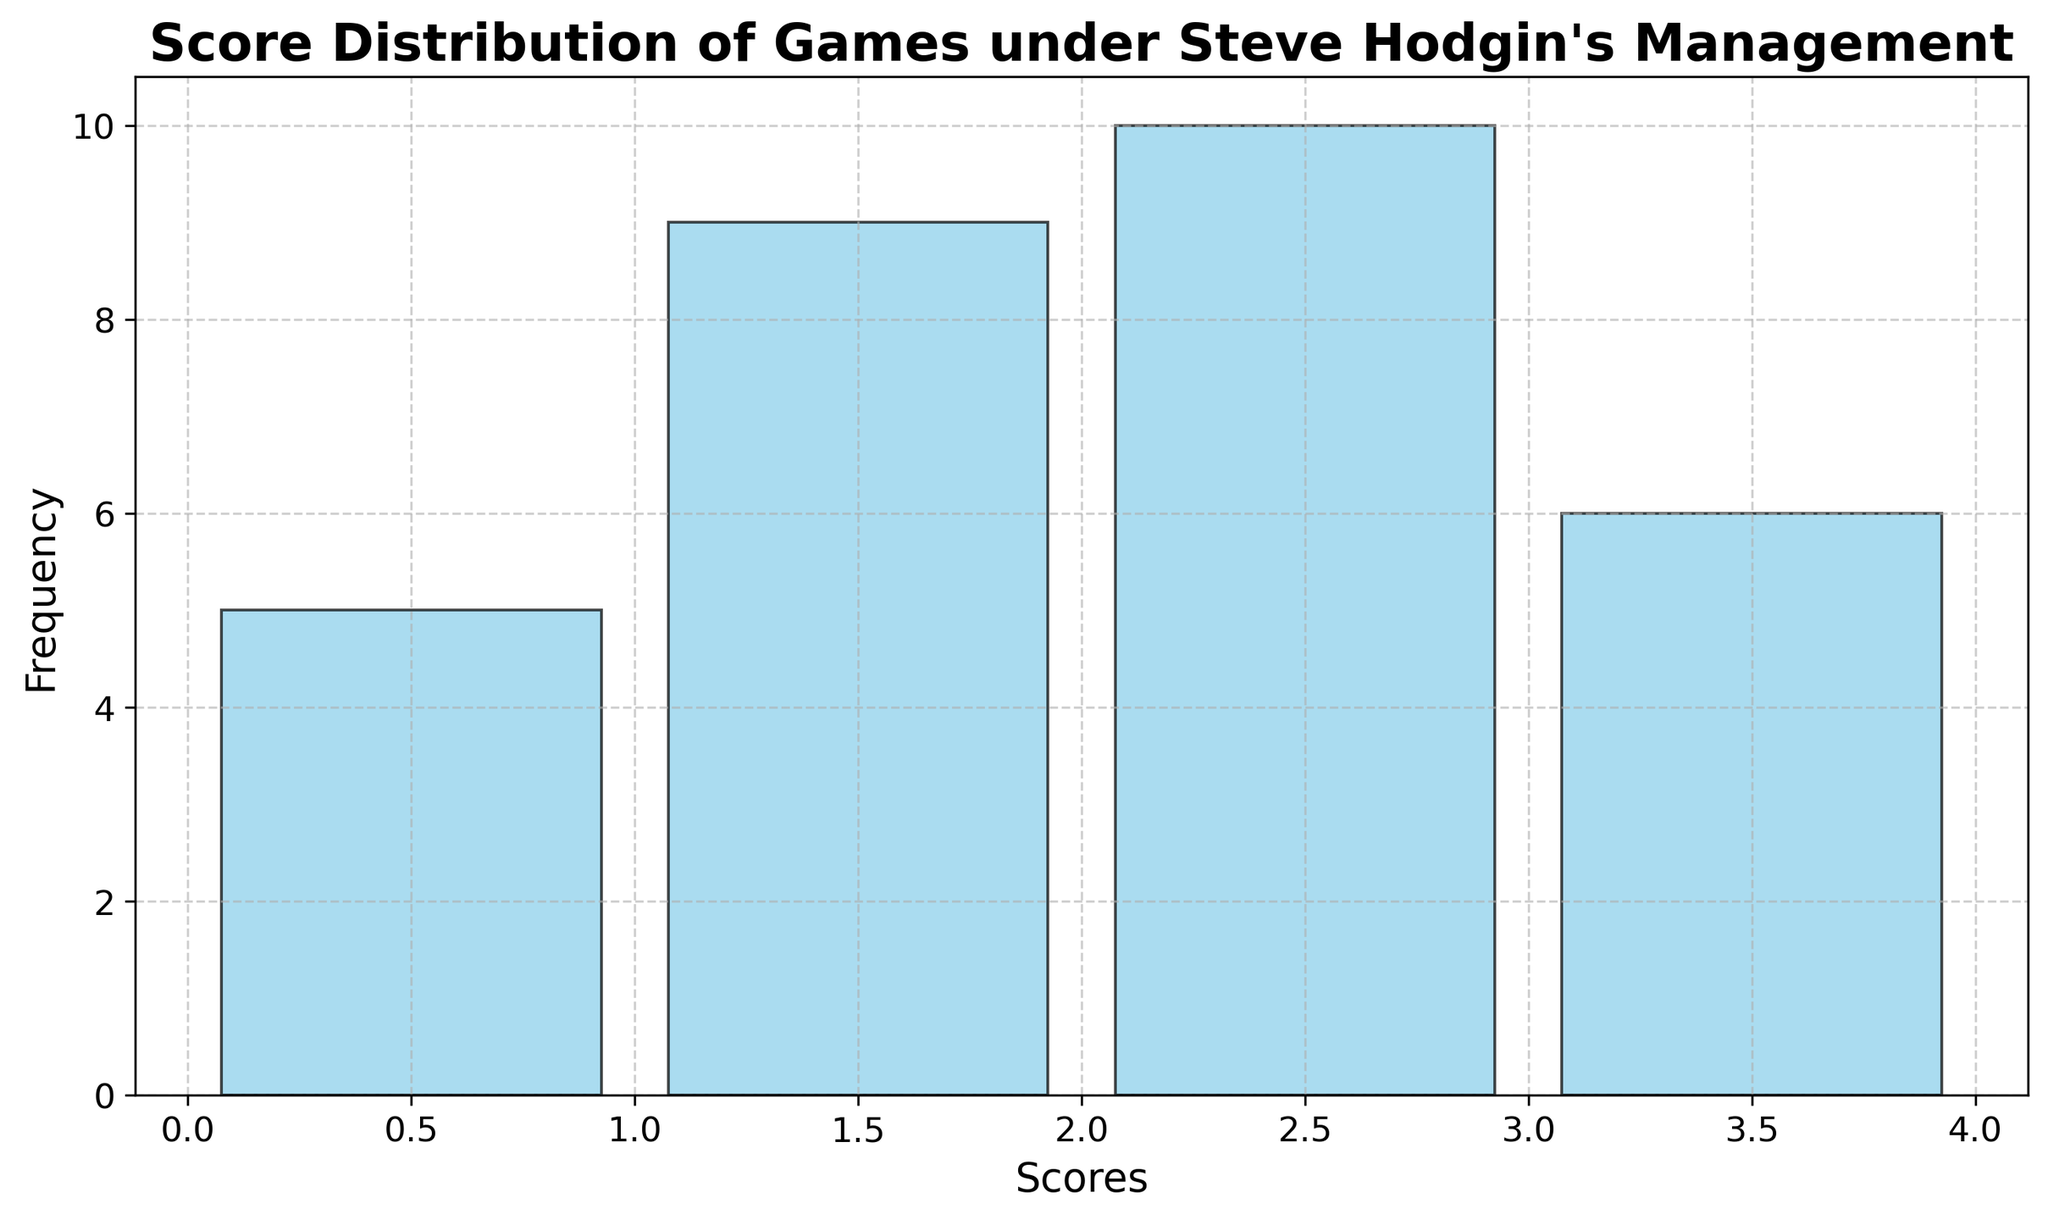Which score was most frequent? The height of the bars in a histogram represents frequency. The bar for the score '2' is the tallest.
Answer: 2 How many games had a score of 0? From the histogram, count the frequency of the bar labeled '0'.
Answer: 5 What is the total number of games that had scores of either 0 or 1? Add the frequencies of the bars labeled '0' and '1'. The frequency of '0' is 5 and the frequency of '1' is 10. 5 + 10 = 15.
Answer: 15 Which score had the least frequency? The height of the bar representing the score '0' is the shortest among all bars.
Answer: 0 Are there more games with a score of 2 than with a score of 3? Compare the heights of the bars for scores '2' and '3'. The bar for '2' is taller than the bar for '3'.
Answer: Yes What's the difference in the number of games with scores of 2 and 1? Calculate the absolute difference between the frequencies of scores '2' and '1'. The frequency of '2' is 10 and '1' is 10. 10 - 10 = 0.
Answer: 0 How many total games were played under Steve Hodgin's management? Sum the frequencies of all the bars in the histogram. Total = 5 (0) + 10 (1) + 10 (2) + 5 (3) = 30.
Answer: 30 What score range has the highest frequency? From the histogram, identify the score range with highest bar. Scores '2' have the highest frequency bar.
Answer: 2 Compare the cumulative frequency of scores 0 and 1 vs scores 2 and 3. Which is higher? Calculate the cumulative frequency of scores 0 and 1 (5+10=15) and of scores 2 and 3 (10+5=15). Both are equal.
Answer: Equal What percentage of games had a score of 2? Calculate the proportion of games with a score of 2 out of the total games played, and then convert it to a percentage. There are 10 games with a score of 2 out of a total of 30 games. (10/30) * 100 = 33.33%.
Answer: 33.33% 